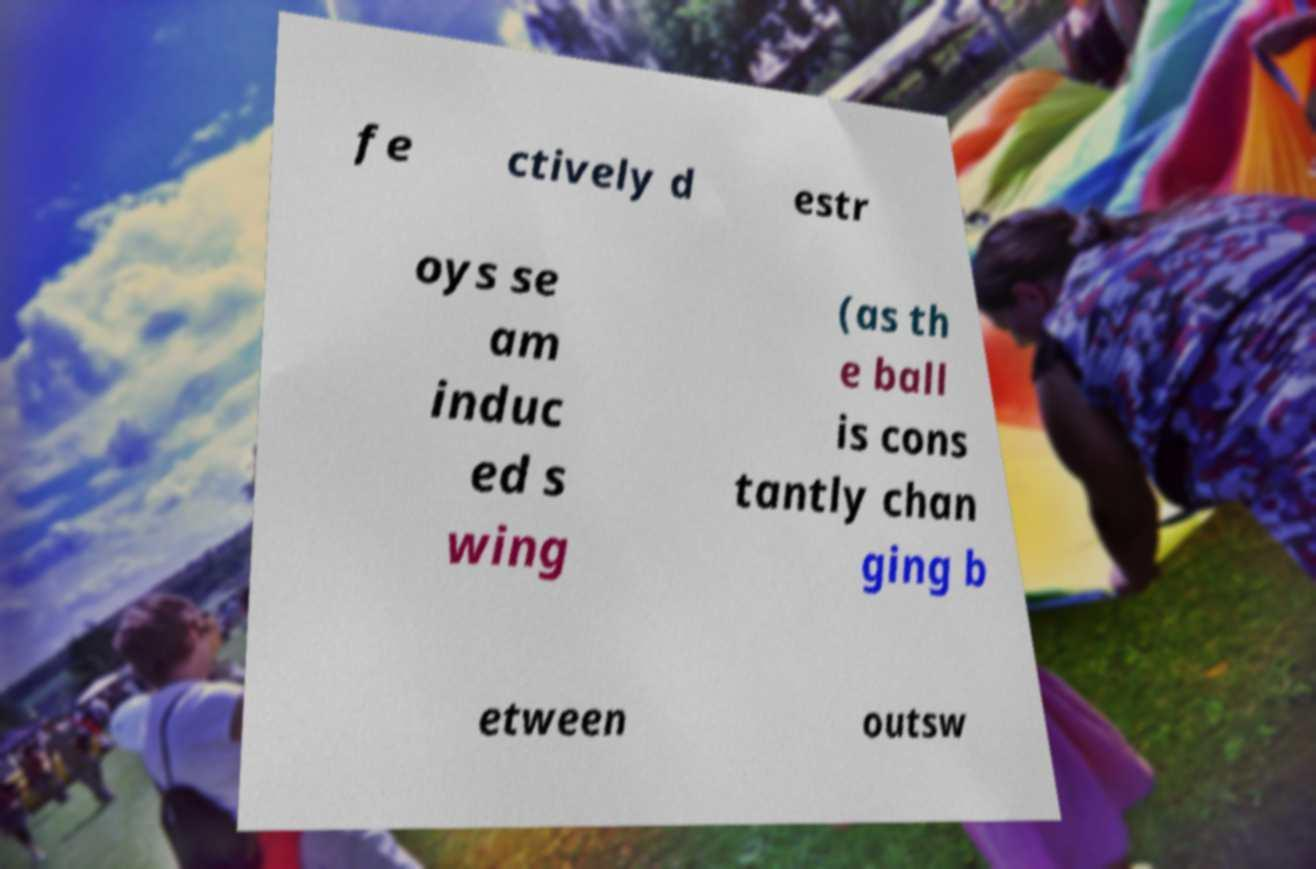For documentation purposes, I need the text within this image transcribed. Could you provide that? fe ctively d estr oys se am induc ed s wing (as th e ball is cons tantly chan ging b etween outsw 